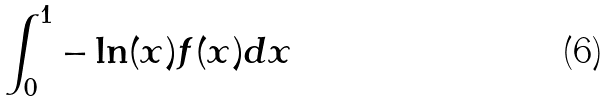<formula> <loc_0><loc_0><loc_500><loc_500>\int _ { 0 } ^ { 1 } - \ln ( x ) f ( x ) d x</formula> 